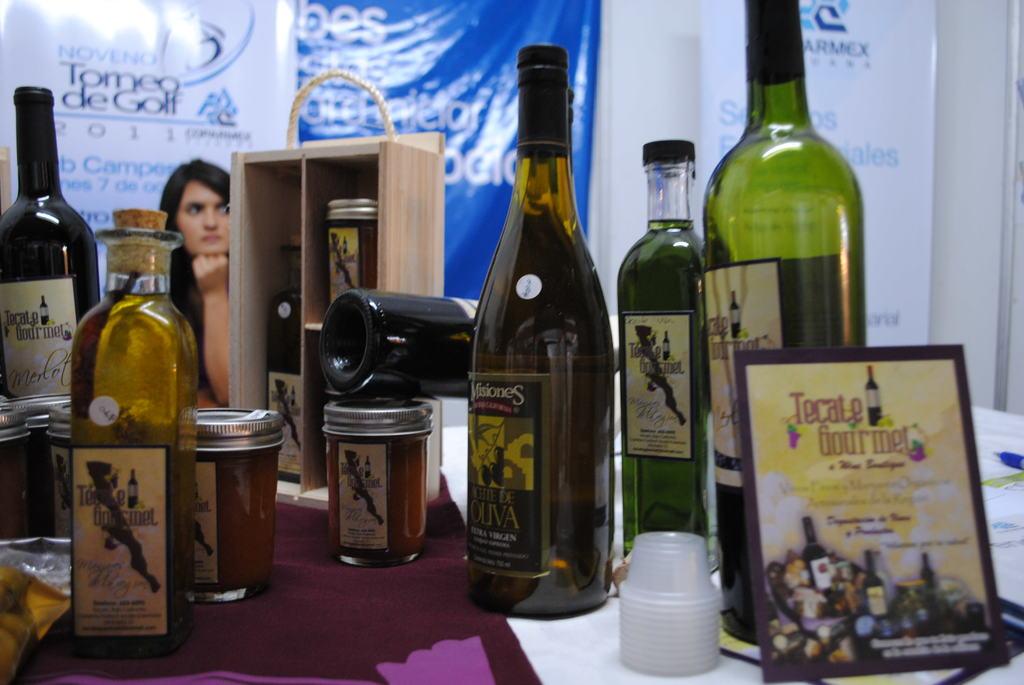What type of gourmet?
Make the answer very short. Tecate. What is the brand of the bottles?
Give a very brief answer. Tecate gourmet. 